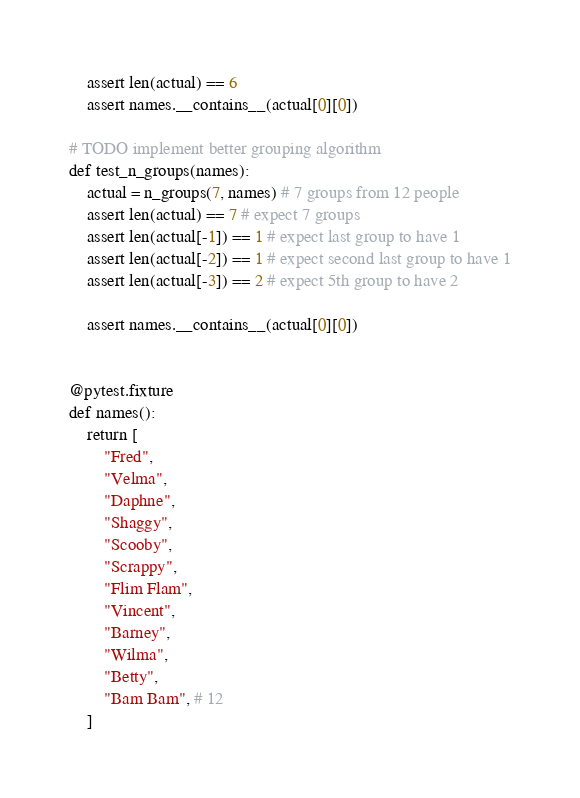Convert code to text. <code><loc_0><loc_0><loc_500><loc_500><_Python_>    assert len(actual) == 6
    assert names.__contains__(actual[0][0])

# TODO implement better grouping algorithm
def test_n_groups(names):
    actual = n_groups(7, names) # 7 groups from 12 people
    assert len(actual) == 7 # expect 7 groups
    assert len(actual[-1]) == 1 # expect last group to have 1
    assert len(actual[-2]) == 1 # expect second last group to have 1
    assert len(actual[-3]) == 2 # expect 5th group to have 2

    assert names.__contains__(actual[0][0])


@pytest.fixture
def names():
    return [
        "Fred",
        "Velma",
        "Daphne",
        "Shaggy",
        "Scooby",
        "Scrappy",
        "Flim Flam",
        "Vincent",
        "Barney",
        "Wilma",
        "Betty",
        "Bam Bam", # 12
    ]
</code> 